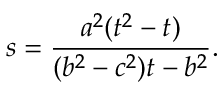<formula> <loc_0><loc_0><loc_500><loc_500>s = \frac { a ^ { 2 } ( t ^ { 2 } - t ) } { ( b ^ { 2 } - c ^ { 2 } ) t - b ^ { 2 } } .</formula> 